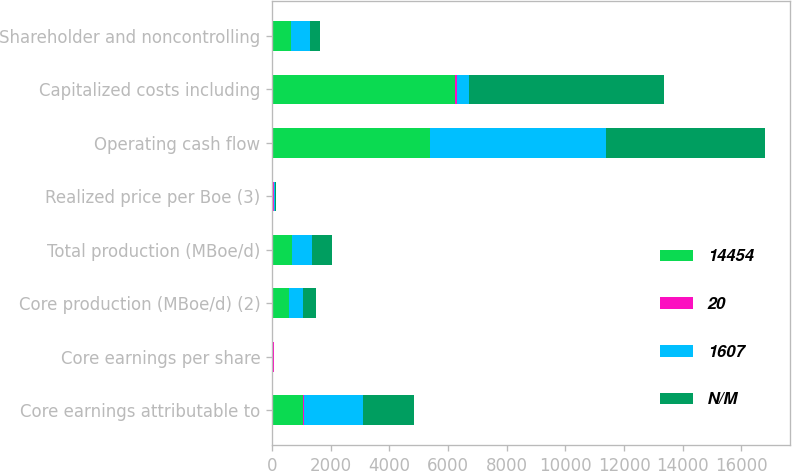Convert chart to OTSL. <chart><loc_0><loc_0><loc_500><loc_500><stacked_bar_chart><ecel><fcel>Core earnings attributable to<fcel>Core earnings per share<fcel>Core production (MBoe/d) (2)<fcel>Total production (MBoe/d)<fcel>Realized price per Boe (3)<fcel>Operating cash flow<fcel>Capitalized costs including<fcel>Shareholder and noncontrolling<nl><fcel>14454<fcel>1044<fcel>2.52<fcel>560<fcel>680<fcel>21.68<fcel>5383<fcel>6233<fcel>650<nl><fcel>20<fcel>48<fcel>49<fcel>15<fcel>1<fcel>46<fcel>10<fcel>54<fcel>5<nl><fcel>1607<fcel>2017<fcel>4.91<fcel>489<fcel>673<fcel>40.33<fcel>5981<fcel>423<fcel>621<nl><fcel>N/M<fcel>1734<fcel>4.26<fcel>423<fcel>693<fcel>33.7<fcel>5436<fcel>6643<fcel>348<nl></chart> 